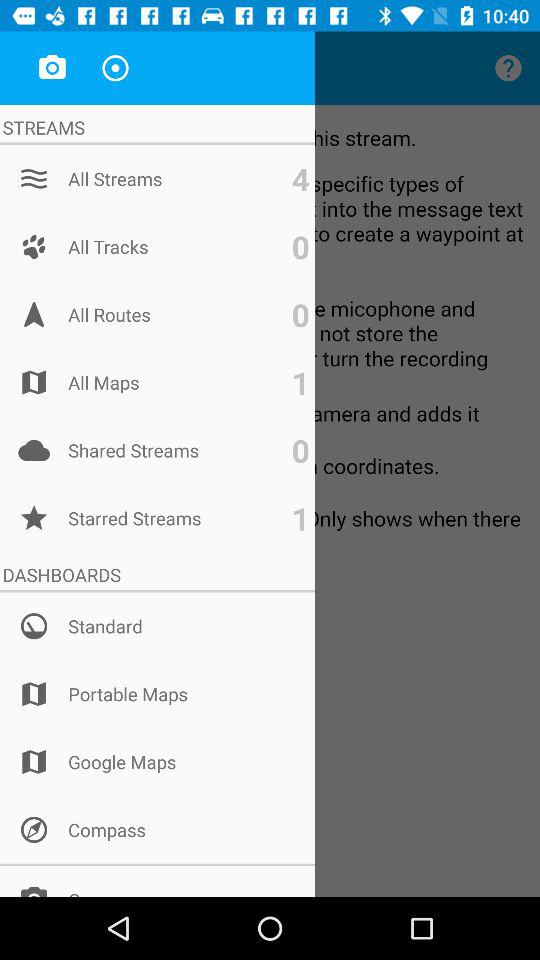What is the number of "Starred Streams"? The number of "Starred Streams" is 1. 